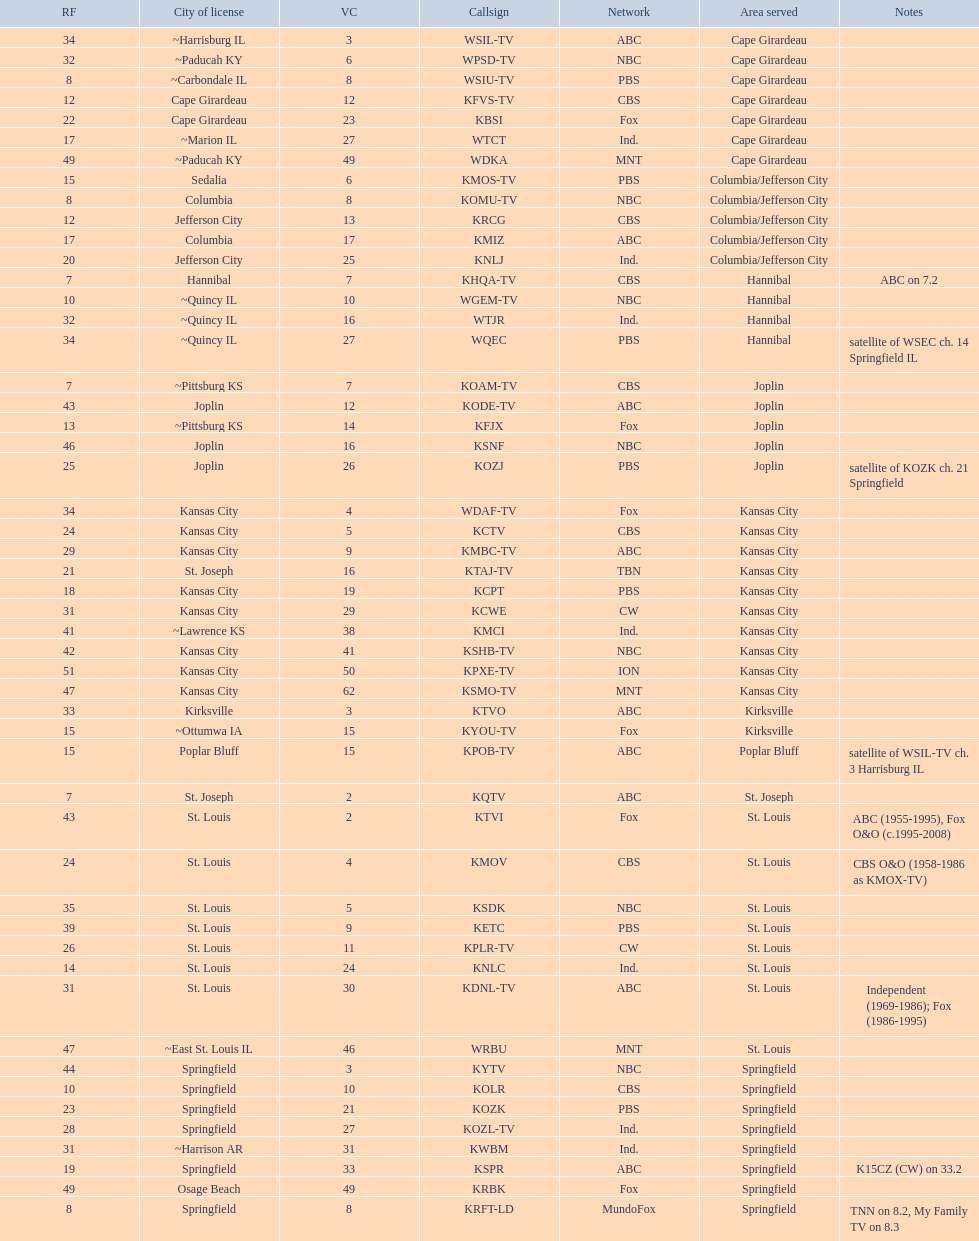How many areas have at least 5 stations? 6. Give me the full table as a dictionary. {'header': ['RF', 'City of license', 'VC', 'Callsign', 'Network', 'Area served', 'Notes'], 'rows': [['34', '~Harrisburg IL', '3', 'WSIL-TV', 'ABC', 'Cape Girardeau', ''], ['32', '~Paducah KY', '6', 'WPSD-TV', 'NBC', 'Cape Girardeau', ''], ['8', '~Carbondale IL', '8', 'WSIU-TV', 'PBS', 'Cape Girardeau', ''], ['12', 'Cape Girardeau', '12', 'KFVS-TV', 'CBS', 'Cape Girardeau', ''], ['22', 'Cape Girardeau', '23', 'KBSI', 'Fox', 'Cape Girardeau', ''], ['17', '~Marion IL', '27', 'WTCT', 'Ind.', 'Cape Girardeau', ''], ['49', '~Paducah KY', '49', 'WDKA', 'MNT', 'Cape Girardeau', ''], ['15', 'Sedalia', '6', 'KMOS-TV', 'PBS', 'Columbia/Jefferson City', ''], ['8', 'Columbia', '8', 'KOMU-TV', 'NBC', 'Columbia/Jefferson City', ''], ['12', 'Jefferson City', '13', 'KRCG', 'CBS', 'Columbia/Jefferson City', ''], ['17', 'Columbia', '17', 'KMIZ', 'ABC', 'Columbia/Jefferson City', ''], ['20', 'Jefferson City', '25', 'KNLJ', 'Ind.', 'Columbia/Jefferson City', ''], ['7', 'Hannibal', '7', 'KHQA-TV', 'CBS', 'Hannibal', 'ABC on 7.2'], ['10', '~Quincy IL', '10', 'WGEM-TV', 'NBC', 'Hannibal', ''], ['32', '~Quincy IL', '16', 'WTJR', 'Ind.', 'Hannibal', ''], ['34', '~Quincy IL', '27', 'WQEC', 'PBS', 'Hannibal', 'satellite of WSEC ch. 14 Springfield IL'], ['7', '~Pittsburg KS', '7', 'KOAM-TV', 'CBS', 'Joplin', ''], ['43', 'Joplin', '12', 'KODE-TV', 'ABC', 'Joplin', ''], ['13', '~Pittsburg KS', '14', 'KFJX', 'Fox', 'Joplin', ''], ['46', 'Joplin', '16', 'KSNF', 'NBC', 'Joplin', ''], ['25', 'Joplin', '26', 'KOZJ', 'PBS', 'Joplin', 'satellite of KOZK ch. 21 Springfield'], ['34', 'Kansas City', '4', 'WDAF-TV', 'Fox', 'Kansas City', ''], ['24', 'Kansas City', '5', 'KCTV', 'CBS', 'Kansas City', ''], ['29', 'Kansas City', '9', 'KMBC-TV', 'ABC', 'Kansas City', ''], ['21', 'St. Joseph', '16', 'KTAJ-TV', 'TBN', 'Kansas City', ''], ['18', 'Kansas City', '19', 'KCPT', 'PBS', 'Kansas City', ''], ['31', 'Kansas City', '29', 'KCWE', 'CW', 'Kansas City', ''], ['41', '~Lawrence KS', '38', 'KMCI', 'Ind.', 'Kansas City', ''], ['42', 'Kansas City', '41', 'KSHB-TV', 'NBC', 'Kansas City', ''], ['51', 'Kansas City', '50', 'KPXE-TV', 'ION', 'Kansas City', ''], ['47', 'Kansas City', '62', 'KSMO-TV', 'MNT', 'Kansas City', ''], ['33', 'Kirksville', '3', 'KTVO', 'ABC', 'Kirksville', ''], ['15', '~Ottumwa IA', '15', 'KYOU-TV', 'Fox', 'Kirksville', ''], ['15', 'Poplar Bluff', '15', 'KPOB-TV', 'ABC', 'Poplar Bluff', 'satellite of WSIL-TV ch. 3 Harrisburg IL'], ['7', 'St. Joseph', '2', 'KQTV', 'ABC', 'St. Joseph', ''], ['43', 'St. Louis', '2', 'KTVI', 'Fox', 'St. Louis', 'ABC (1955-1995), Fox O&O (c.1995-2008)'], ['24', 'St. Louis', '4', 'KMOV', 'CBS', 'St. Louis', 'CBS O&O (1958-1986 as KMOX-TV)'], ['35', 'St. Louis', '5', 'KSDK', 'NBC', 'St. Louis', ''], ['39', 'St. Louis', '9', 'KETC', 'PBS', 'St. Louis', ''], ['26', 'St. Louis', '11', 'KPLR-TV', 'CW', 'St. Louis', ''], ['14', 'St. Louis', '24', 'KNLC', 'Ind.', 'St. Louis', ''], ['31', 'St. Louis', '30', 'KDNL-TV', 'ABC', 'St. Louis', 'Independent (1969-1986); Fox (1986-1995)'], ['47', '~East St. Louis IL', '46', 'WRBU', 'MNT', 'St. Louis', ''], ['44', 'Springfield', '3', 'KYTV', 'NBC', 'Springfield', ''], ['10', 'Springfield', '10', 'KOLR', 'CBS', 'Springfield', ''], ['23', 'Springfield', '21', 'KOZK', 'PBS', 'Springfield', ''], ['28', 'Springfield', '27', 'KOZL-TV', 'Ind.', 'Springfield', ''], ['31', '~Harrison AR', '31', 'KWBM', 'Ind.', 'Springfield', ''], ['19', 'Springfield', '33', 'KSPR', 'ABC', 'Springfield', 'K15CZ (CW) on 33.2'], ['49', 'Osage Beach', '49', 'KRBK', 'Fox', 'Springfield', ''], ['8', 'Springfield', '8', 'KRFT-LD', 'MundoFox', 'Springfield', 'TNN on 8.2, My Family TV on 8.3']]} 